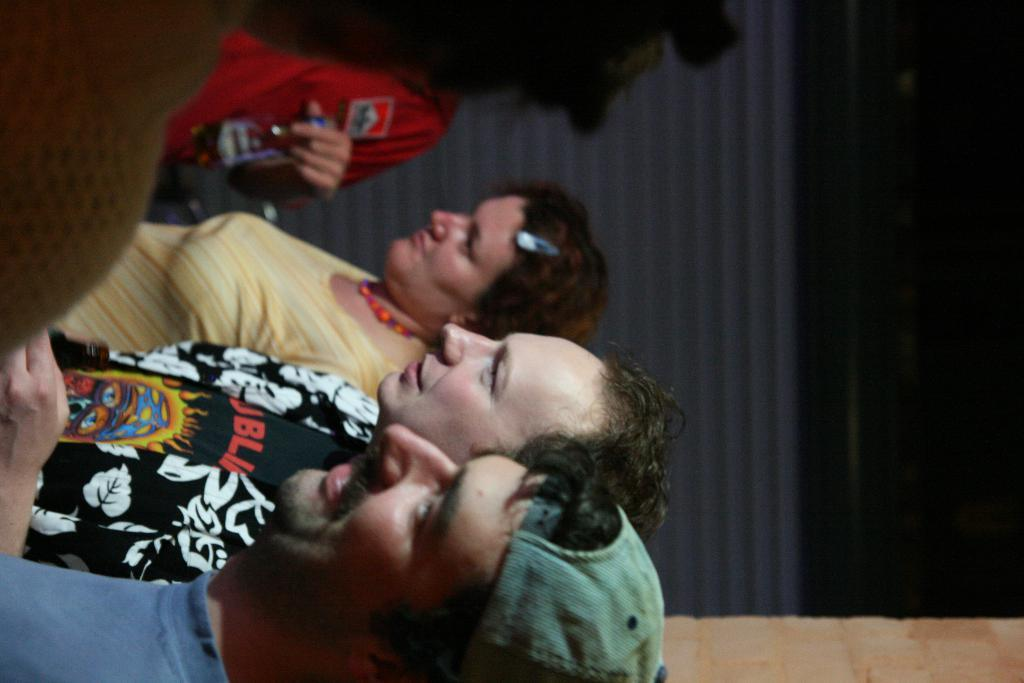What can be observed about the people in the image? There are people standing in the image. What else is visible in the image besides the people? There is a shutter visible in the image. How much money is being exchanged between the people in the image? There is no indication of money being exchanged in the image. What type of hat is being worn by the people in the image? There is no hat visible in the image. 